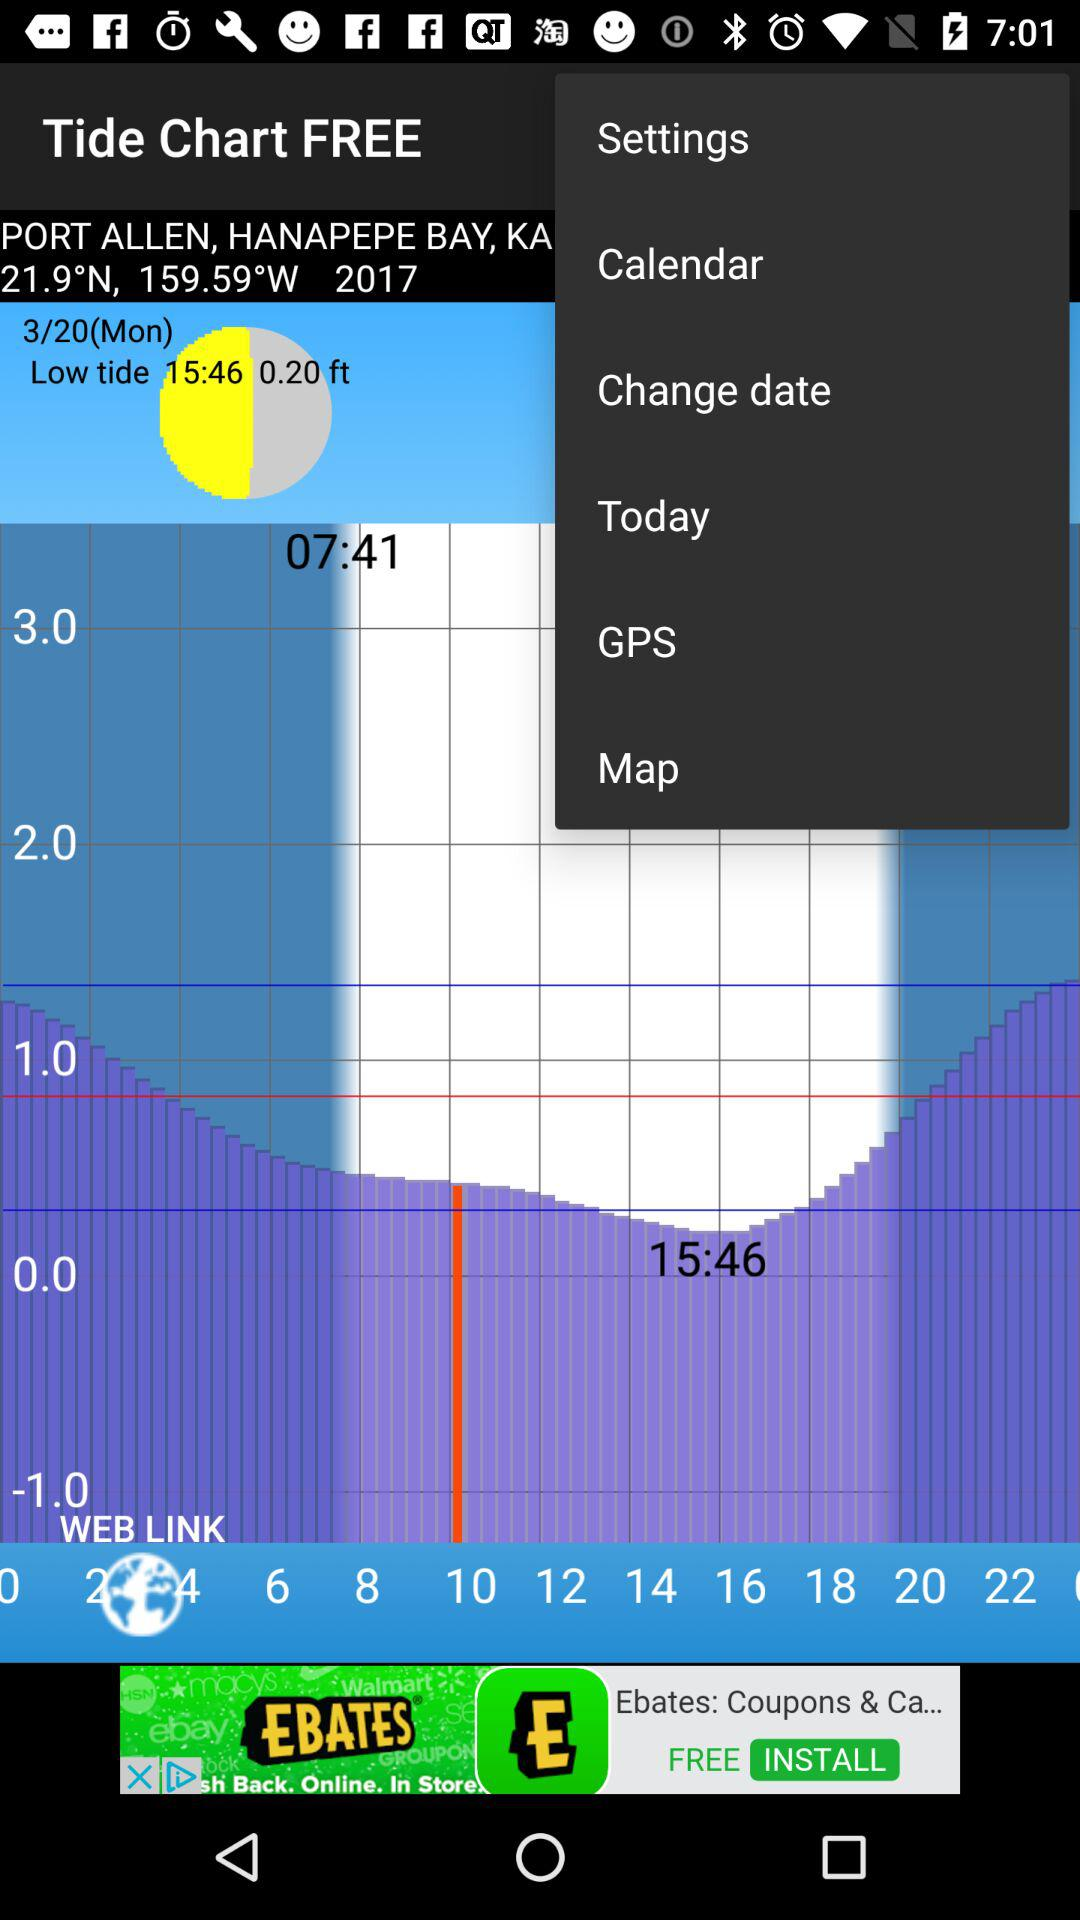What is the selected date? The selected date is Monday, March 20. 